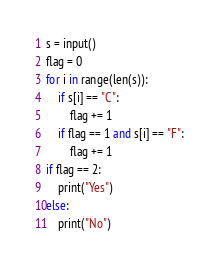<code> <loc_0><loc_0><loc_500><loc_500><_Python_>s = input()
flag = 0
for i in range(len(s)):
    if s[i] == "C":
        flag += 1
    if flag == 1 and s[i] == "F":
        flag += 1
if flag == 2:
    print("Yes")
else:
    print("No")</code> 